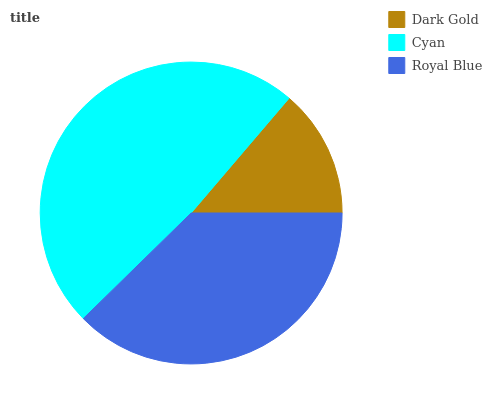Is Dark Gold the minimum?
Answer yes or no. Yes. Is Cyan the maximum?
Answer yes or no. Yes. Is Royal Blue the minimum?
Answer yes or no. No. Is Royal Blue the maximum?
Answer yes or no. No. Is Cyan greater than Royal Blue?
Answer yes or no. Yes. Is Royal Blue less than Cyan?
Answer yes or no. Yes. Is Royal Blue greater than Cyan?
Answer yes or no. No. Is Cyan less than Royal Blue?
Answer yes or no. No. Is Royal Blue the high median?
Answer yes or no. Yes. Is Royal Blue the low median?
Answer yes or no. Yes. Is Dark Gold the high median?
Answer yes or no. No. Is Cyan the low median?
Answer yes or no. No. 